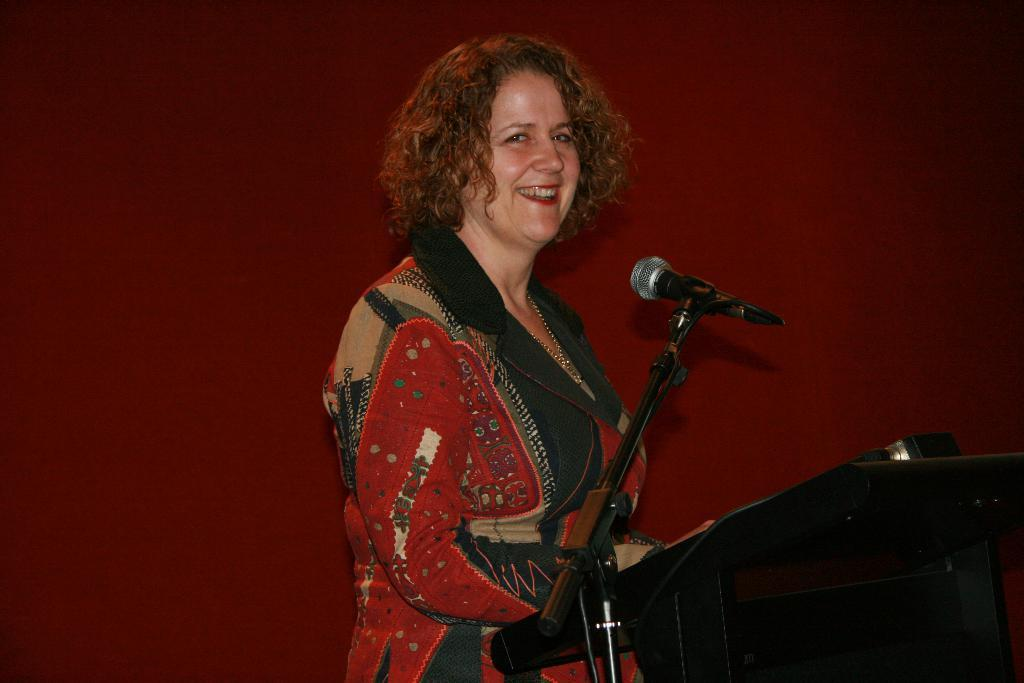Who is the main subject in the image? There is a lady in the center of the image. What is the lady doing in the image? The lady is standing in front of a podium. What object is on the podium? A microphone is present on the podium. What can be seen behind the lady? There is a wall in the background of the image. What type of chess pieces can be seen on the wall in the image? There are no chess pieces visible on the wall in the image. Is the lady playing a guitar in the image? There is no guitar present in the image; the lady is standing in front of a podium with a microphone. 